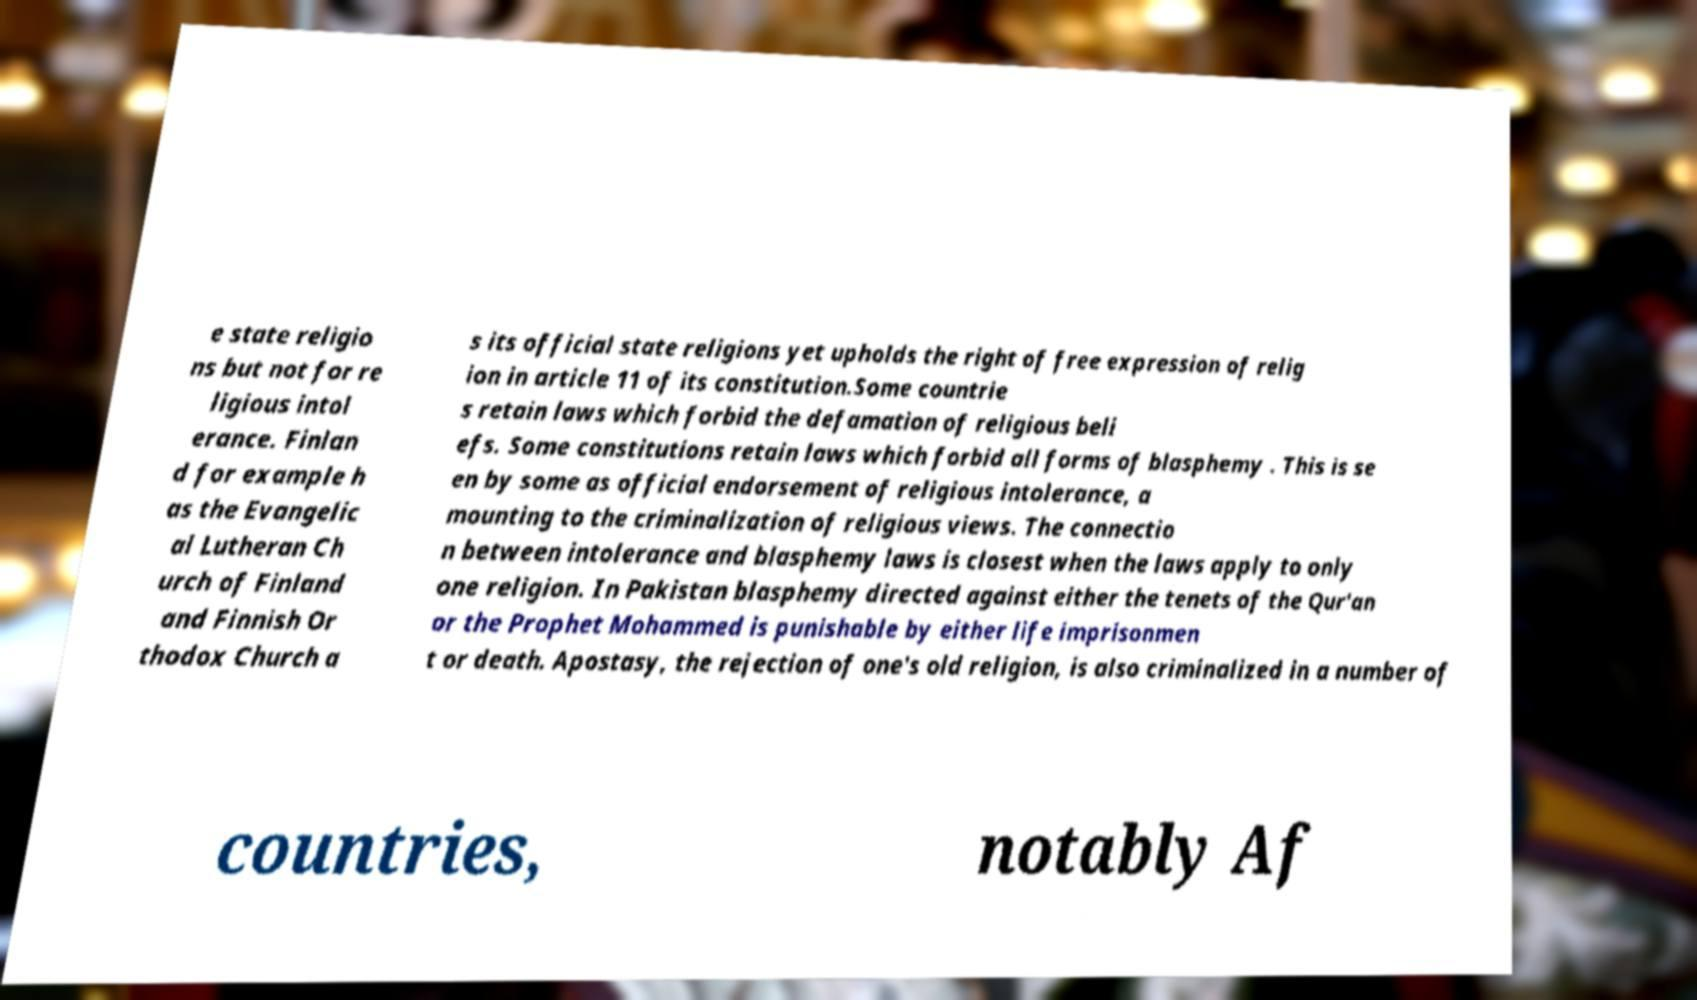Could you assist in decoding the text presented in this image and type it out clearly? e state religio ns but not for re ligious intol erance. Finlan d for example h as the Evangelic al Lutheran Ch urch of Finland and Finnish Or thodox Church a s its official state religions yet upholds the right of free expression of relig ion in article 11 of its constitution.Some countrie s retain laws which forbid the defamation of religious beli efs. Some constitutions retain laws which forbid all forms of blasphemy . This is se en by some as official endorsement of religious intolerance, a mounting to the criminalization of religious views. The connectio n between intolerance and blasphemy laws is closest when the laws apply to only one religion. In Pakistan blasphemy directed against either the tenets of the Qur'an or the Prophet Mohammed is punishable by either life imprisonmen t or death. Apostasy, the rejection of one's old religion, is also criminalized in a number of countries, notably Af 